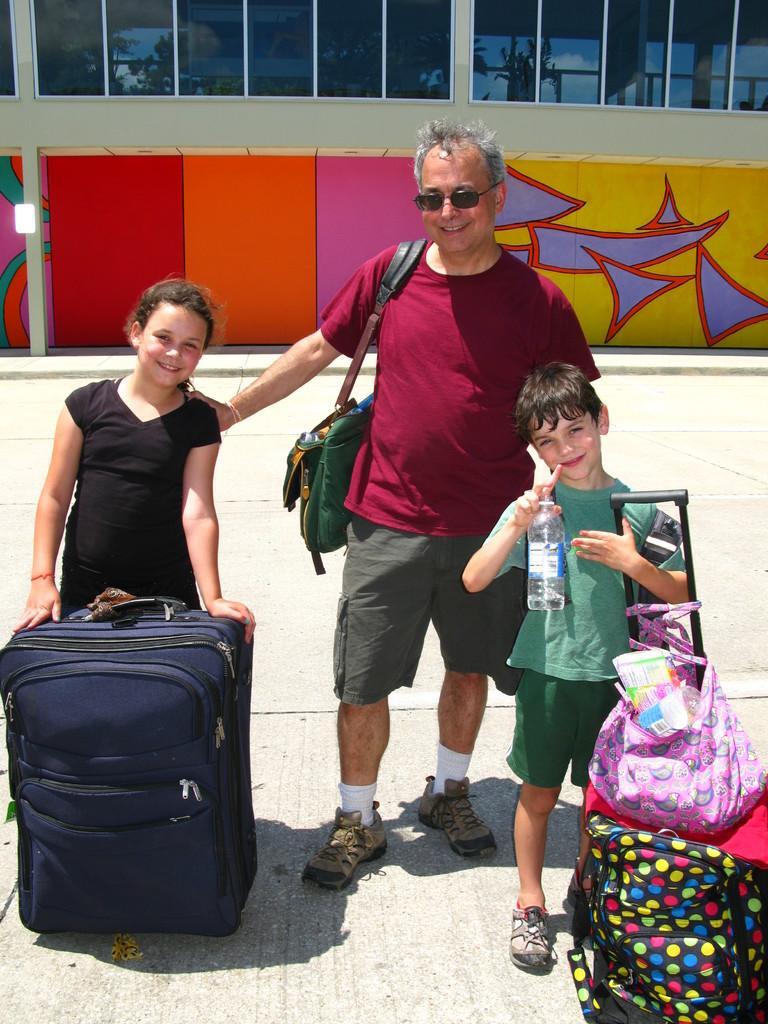How would you summarize this image in a sentence or two? In this image in the middle there is a man he wears t shirt, trouser, handbag and shoes he is smiling. On the right there is a boy he is smiling he holds a bottle and luggage. On the left there is a girl she is smiling she wear black dress. In the background there is a building and window. 